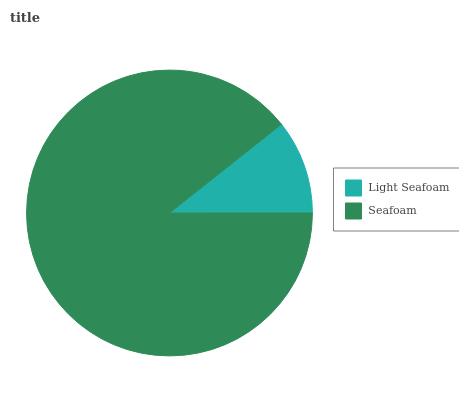Is Light Seafoam the minimum?
Answer yes or no. Yes. Is Seafoam the maximum?
Answer yes or no. Yes. Is Seafoam the minimum?
Answer yes or no. No. Is Seafoam greater than Light Seafoam?
Answer yes or no. Yes. Is Light Seafoam less than Seafoam?
Answer yes or no. Yes. Is Light Seafoam greater than Seafoam?
Answer yes or no. No. Is Seafoam less than Light Seafoam?
Answer yes or no. No. Is Seafoam the high median?
Answer yes or no. Yes. Is Light Seafoam the low median?
Answer yes or no. Yes. Is Light Seafoam the high median?
Answer yes or no. No. Is Seafoam the low median?
Answer yes or no. No. 